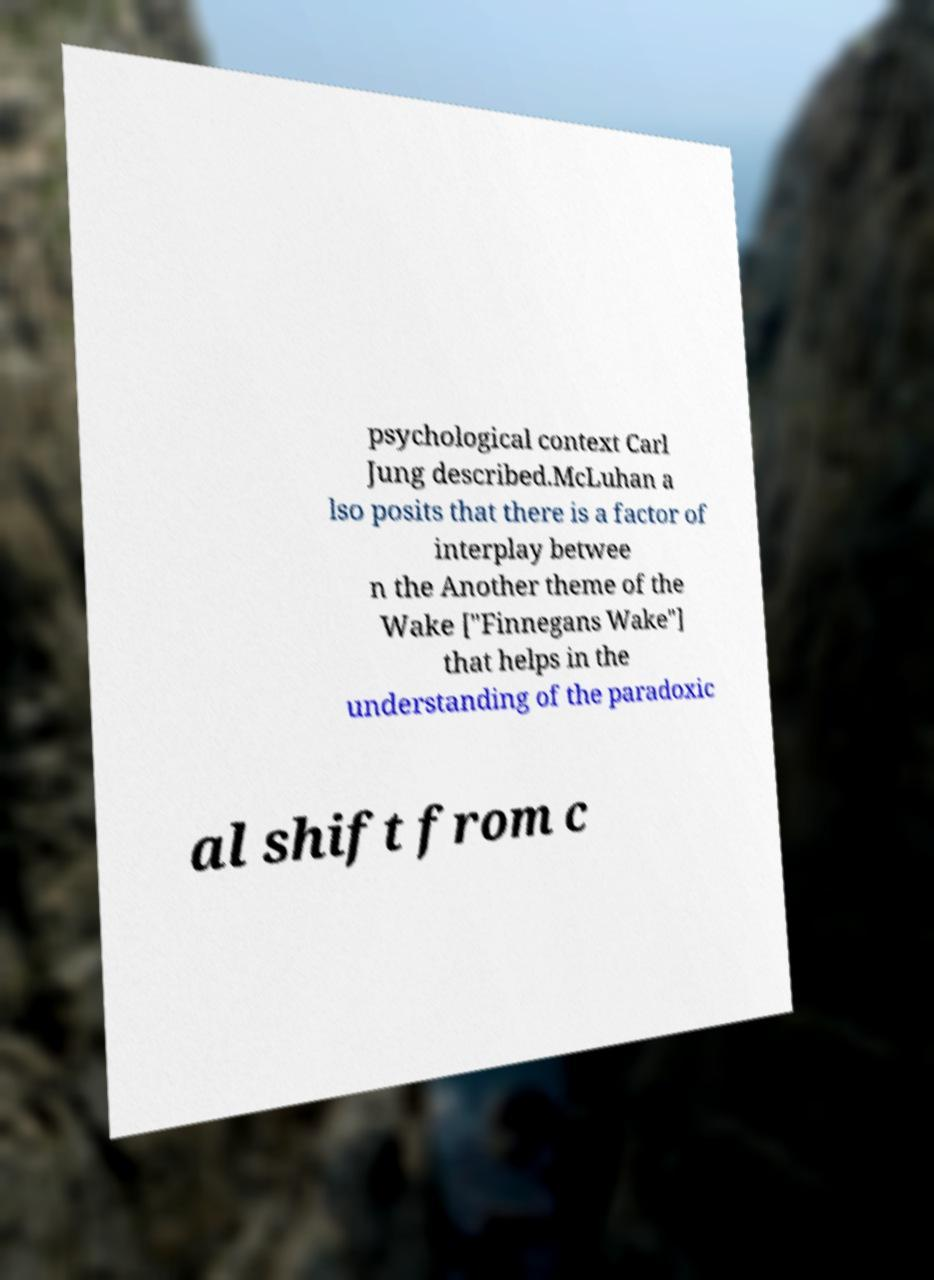Please read and relay the text visible in this image. What does it say? psychological context Carl Jung described.McLuhan a lso posits that there is a factor of interplay betwee n the Another theme of the Wake ["Finnegans Wake"] that helps in the understanding of the paradoxic al shift from c 